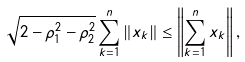<formula> <loc_0><loc_0><loc_500><loc_500>\sqrt { 2 - \rho _ { 1 } ^ { 2 } - \rho _ { 2 } ^ { 2 } } \sum _ { k = 1 } ^ { n } \left \| x _ { k } \right \| \leq \left \| \sum _ { k = 1 } ^ { n } x _ { k } \right \| ,</formula> 